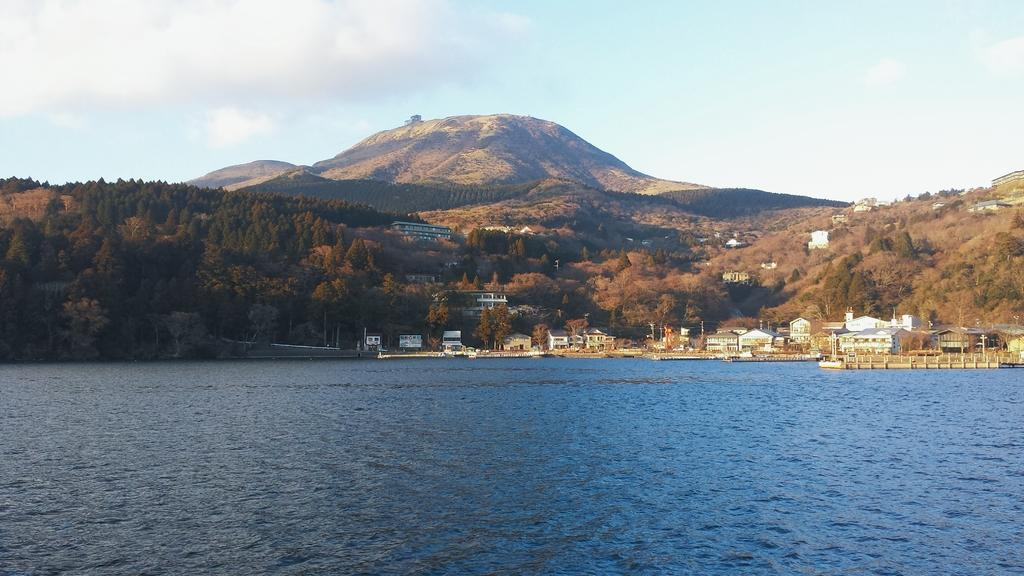What type of natural water feature is present in the picture? There is a river in the picture. What type of man-made structures can be seen in the picture? There are buildings in the picture. What type of vegetation is present in the picture? There are trees in the picture. What type of geological formation is present in the picture? There are mountains in the picture. What is the condition of the sky in the picture? The sky is clear in the picture. How many flowers are present in the picture? There are no flowers present in the picture. How many dogs are present in the picture? There are no dogs present in the picture. 